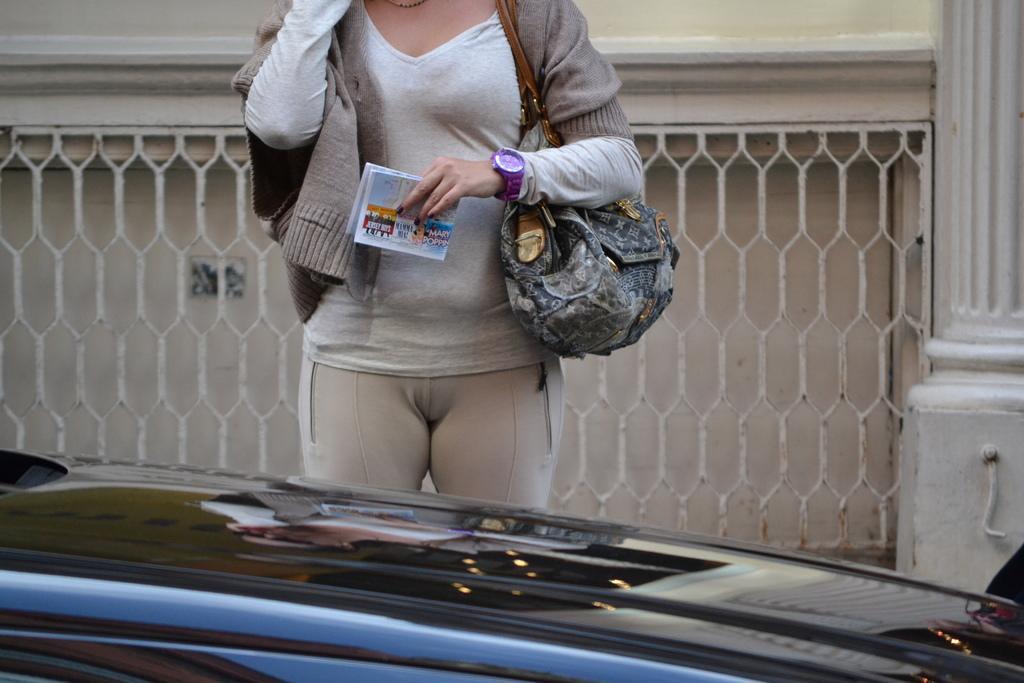How would you summarize this image in a sentence or two? I could see a lady holding a paper in her hand and hand bag standing in front of the black colored car. In the background i could see some grill and wall. 